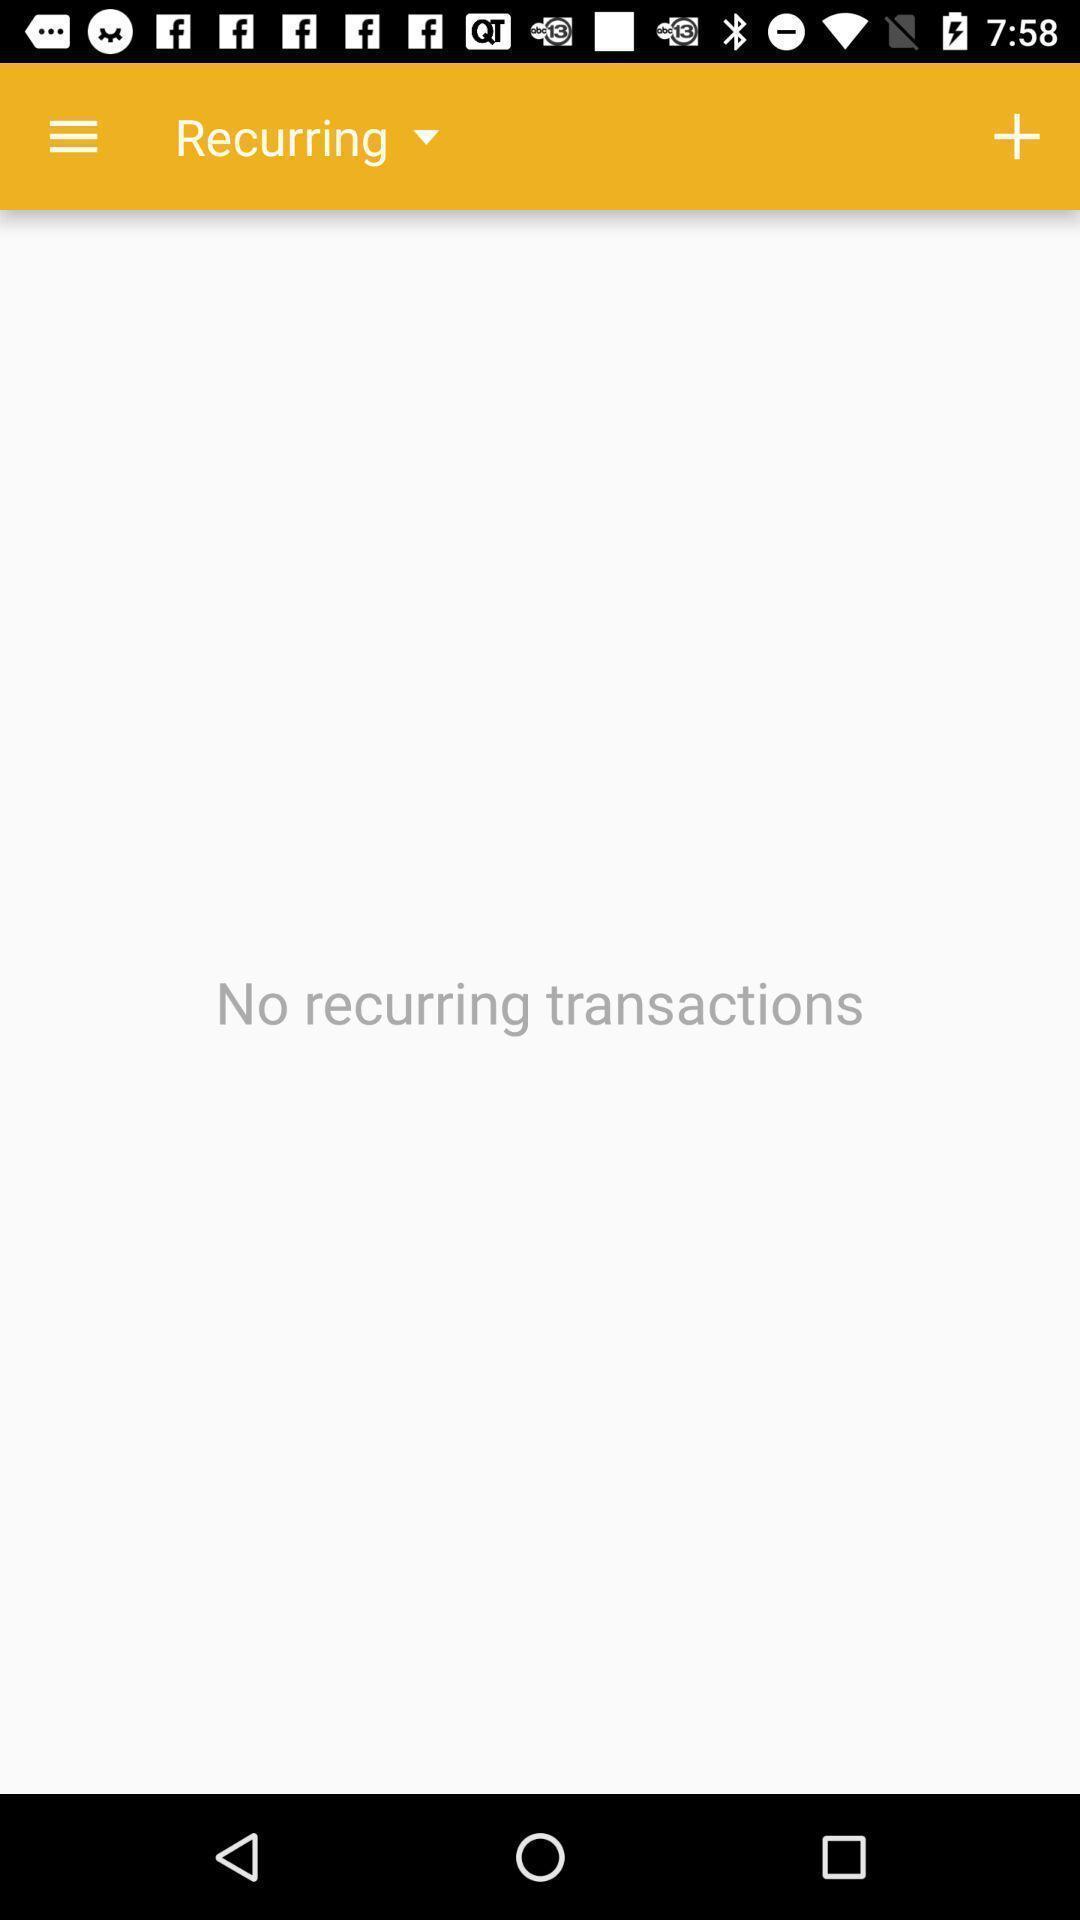Provide a detailed account of this screenshot. Page displaying the recurring transactions. 